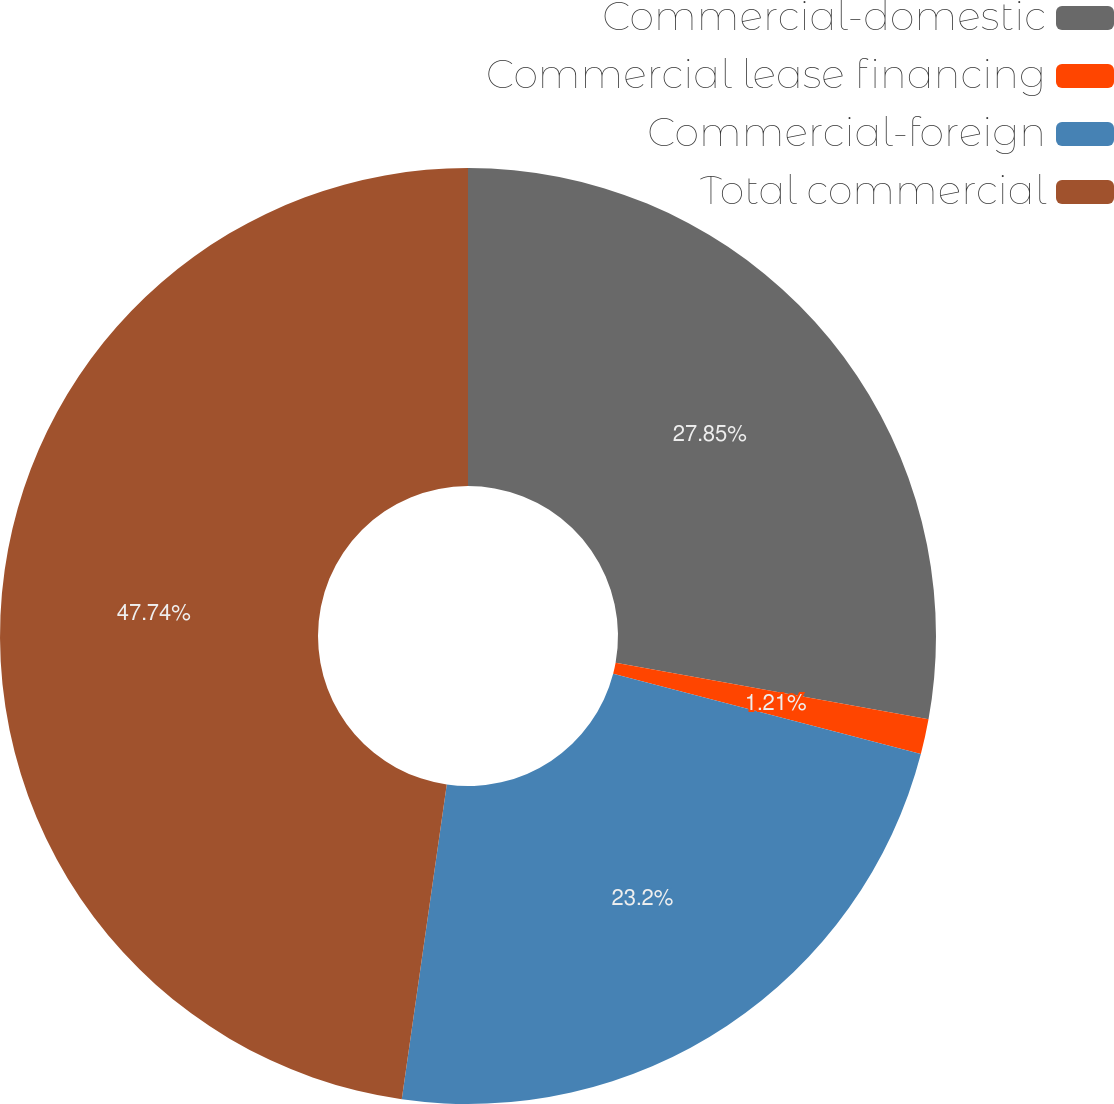<chart> <loc_0><loc_0><loc_500><loc_500><pie_chart><fcel>Commercial-domestic<fcel>Commercial lease financing<fcel>Commercial-foreign<fcel>Total commercial<nl><fcel>27.85%<fcel>1.21%<fcel>23.2%<fcel>47.74%<nl></chart> 